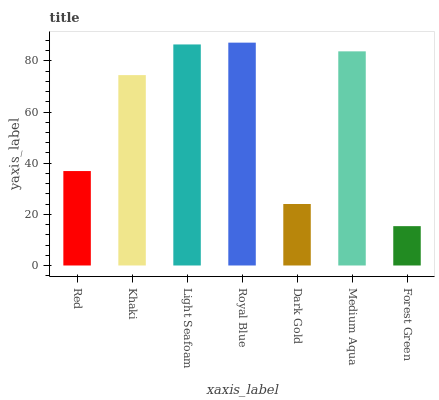Is Khaki the minimum?
Answer yes or no. No. Is Khaki the maximum?
Answer yes or no. No. Is Khaki greater than Red?
Answer yes or no. Yes. Is Red less than Khaki?
Answer yes or no. Yes. Is Red greater than Khaki?
Answer yes or no. No. Is Khaki less than Red?
Answer yes or no. No. Is Khaki the high median?
Answer yes or no. Yes. Is Khaki the low median?
Answer yes or no. Yes. Is Dark Gold the high median?
Answer yes or no. No. Is Royal Blue the low median?
Answer yes or no. No. 